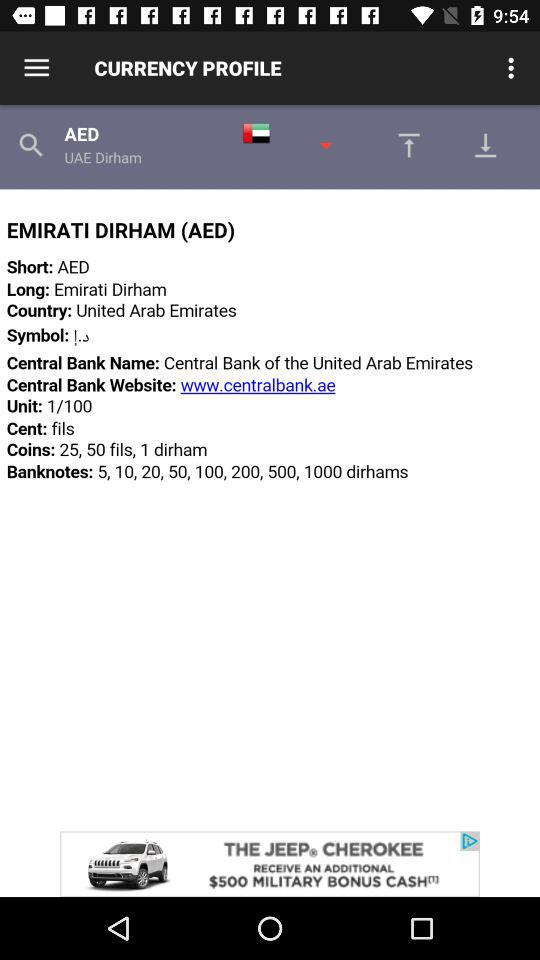What is the short form of the Emirati dirham? The short form is AED. 